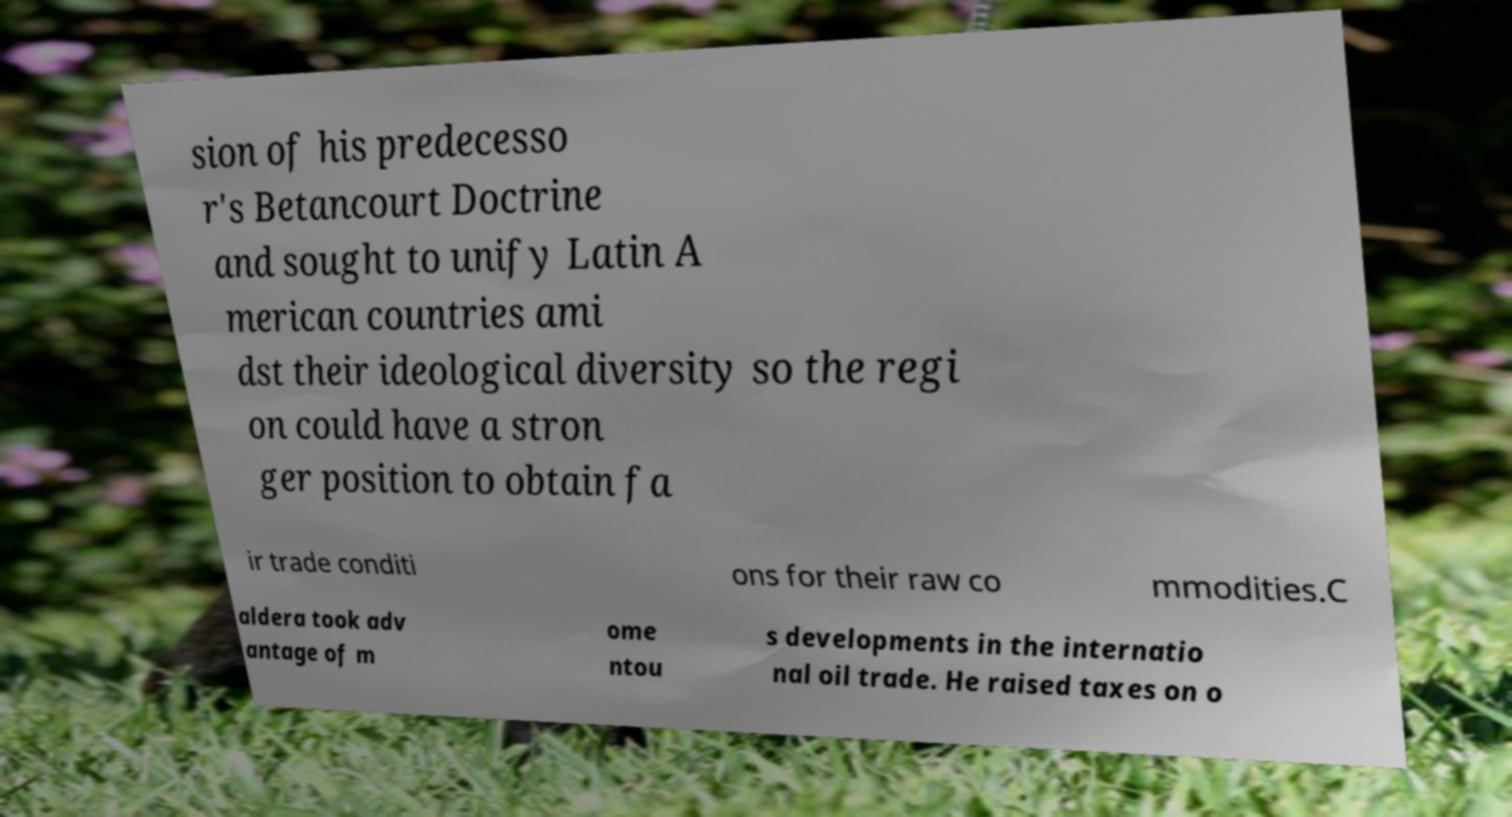Could you extract and type out the text from this image? sion of his predecesso r's Betancourt Doctrine and sought to unify Latin A merican countries ami dst their ideological diversity so the regi on could have a stron ger position to obtain fa ir trade conditi ons for their raw co mmodities.C aldera took adv antage of m ome ntou s developments in the internatio nal oil trade. He raised taxes on o 